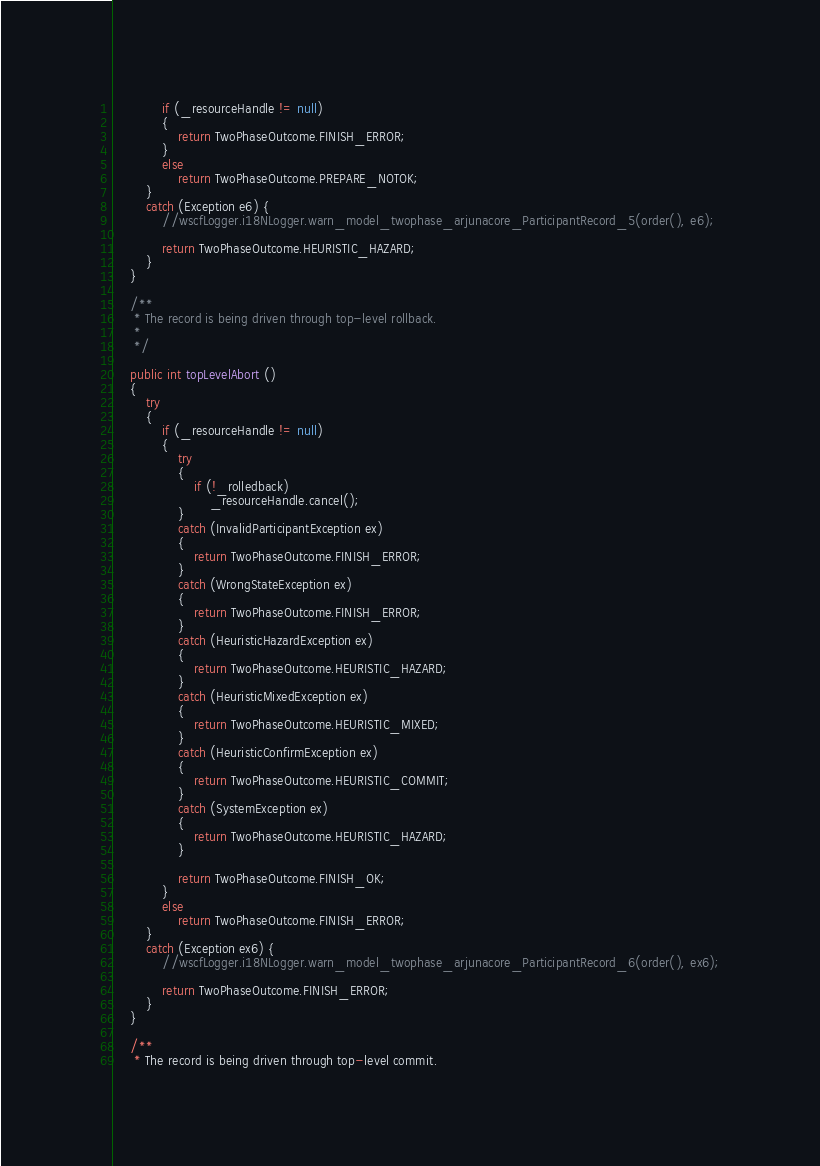<code> <loc_0><loc_0><loc_500><loc_500><_Java_>			if (_resourceHandle != null)
			{
				return TwoPhaseOutcome.FINISH_ERROR;
			}
			else
				return TwoPhaseOutcome.PREPARE_NOTOK;
		}
		catch (Exception e6) {
            //wscfLogger.i18NLogger.warn_model_twophase_arjunacore_ParticipantRecord_5(order(), e6);

            return TwoPhaseOutcome.HEURISTIC_HAZARD;
        }
	}

	/**
	 * The record is being driven through top-level rollback.
	 *
	 */

	public int topLevelAbort ()
	{
		try
		{
			if (_resourceHandle != null)
			{
				try
				{
					if (!_rolledback)
						_resourceHandle.cancel();
				}
				catch (InvalidParticipantException ex)
				{
					return TwoPhaseOutcome.FINISH_ERROR;
				}
				catch (WrongStateException ex)
				{
					return TwoPhaseOutcome.FINISH_ERROR;
				}
				catch (HeuristicHazardException ex)
				{
					return TwoPhaseOutcome.HEURISTIC_HAZARD;
				}
				catch (HeuristicMixedException ex)
				{
					return TwoPhaseOutcome.HEURISTIC_MIXED;
				}
				catch (HeuristicConfirmException ex)
				{
					return TwoPhaseOutcome.HEURISTIC_COMMIT;
				}
				catch (SystemException ex)
				{
					return TwoPhaseOutcome.HEURISTIC_HAZARD;
				}

				return TwoPhaseOutcome.FINISH_OK;
			}
			else
				return TwoPhaseOutcome.FINISH_ERROR;
		}
		catch (Exception ex6) {
            //wscfLogger.i18NLogger.warn_model_twophase_arjunacore_ParticipantRecord_6(order(), ex6);

            return TwoPhaseOutcome.FINISH_ERROR;
        }
	}

	/**
	 * The record is being driven through top-level commit.</code> 